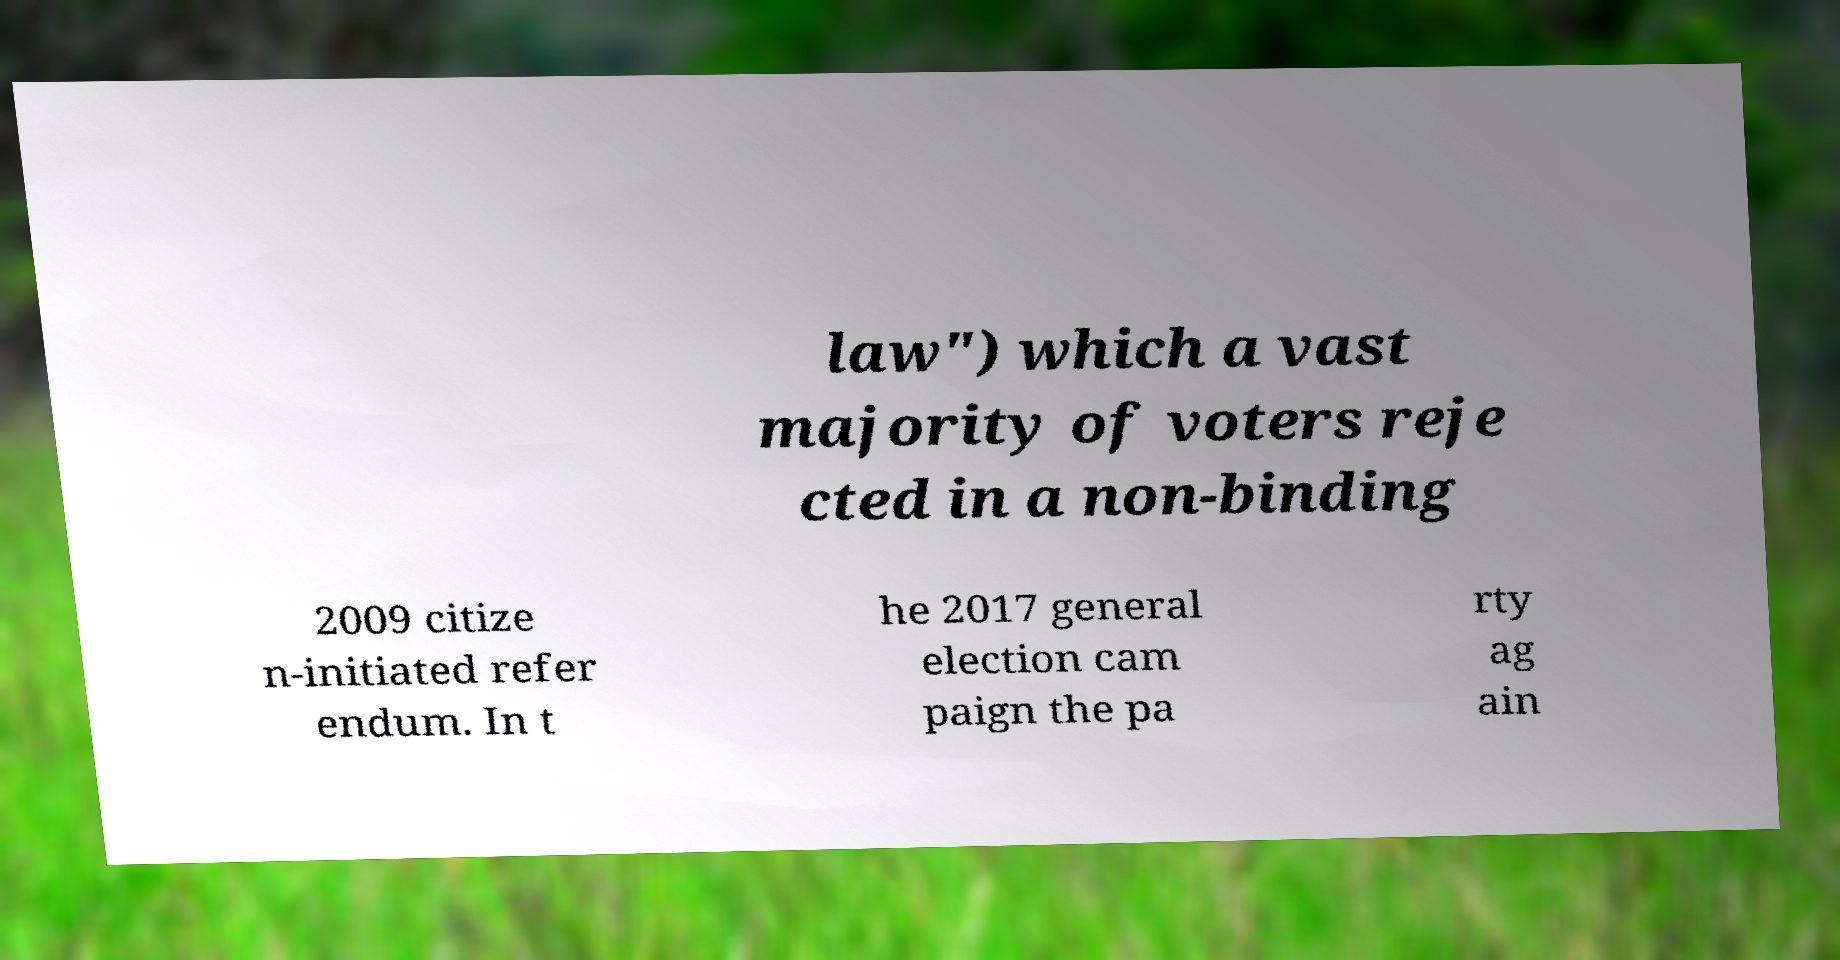For documentation purposes, I need the text within this image transcribed. Could you provide that? law") which a vast majority of voters reje cted in a non-binding 2009 citize n-initiated refer endum. In t he 2017 general election cam paign the pa rty ag ain 